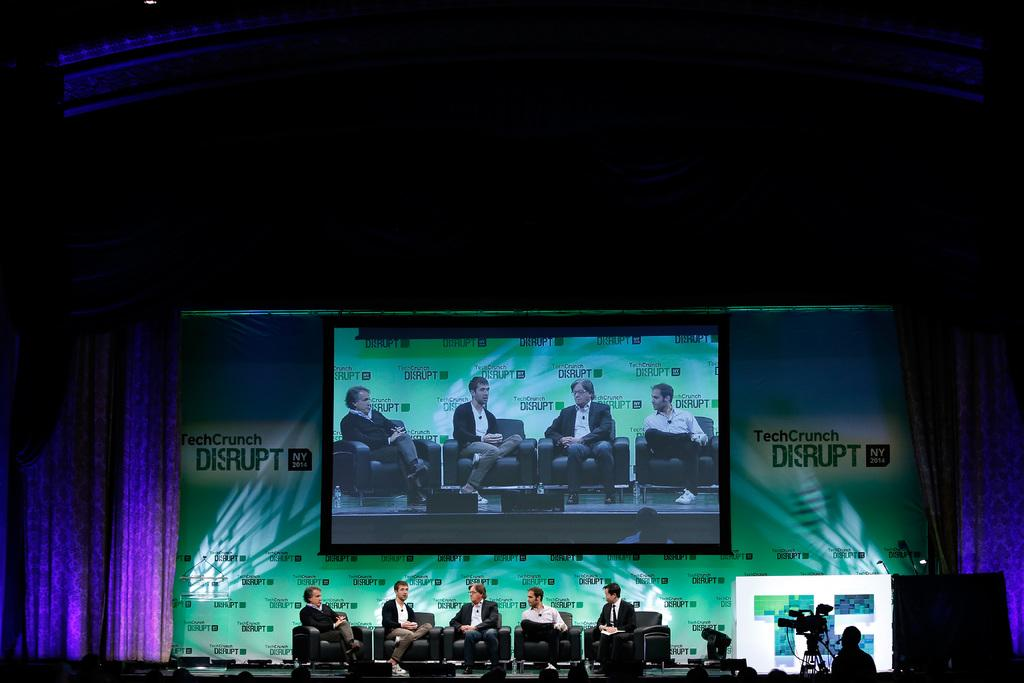<image>
Write a terse but informative summary of the picture. Tech Crunch Disrupt label on a large screen with five men sitting on a stage. 